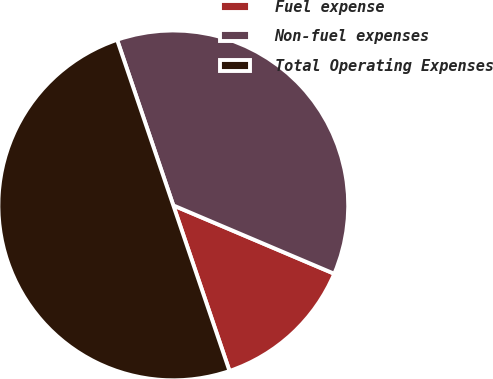Convert chart to OTSL. <chart><loc_0><loc_0><loc_500><loc_500><pie_chart><fcel>Fuel expense<fcel>Non-fuel expenses<fcel>Total Operating Expenses<nl><fcel>13.4%<fcel>36.6%<fcel>50.0%<nl></chart> 